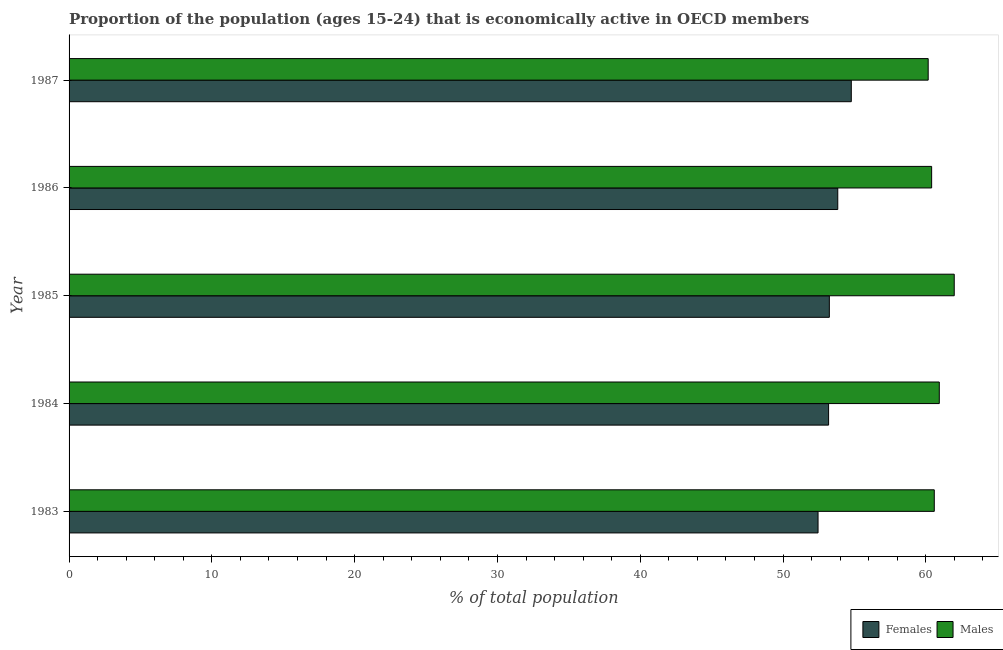How many groups of bars are there?
Offer a terse response. 5. Are the number of bars per tick equal to the number of legend labels?
Offer a terse response. Yes. Are the number of bars on each tick of the Y-axis equal?
Your answer should be very brief. Yes. How many bars are there on the 5th tick from the top?
Your answer should be compact. 2. In how many cases, is the number of bars for a given year not equal to the number of legend labels?
Keep it short and to the point. 0. What is the percentage of economically active male population in 1986?
Ensure brevity in your answer.  60.41. Across all years, what is the maximum percentage of economically active male population?
Ensure brevity in your answer.  61.99. Across all years, what is the minimum percentage of economically active female population?
Offer a terse response. 52.45. In which year was the percentage of economically active female population minimum?
Ensure brevity in your answer.  1983. What is the total percentage of economically active female population in the graph?
Your answer should be very brief. 267.5. What is the difference between the percentage of economically active female population in 1983 and that in 1985?
Keep it short and to the point. -0.79. What is the difference between the percentage of economically active male population in 1985 and the percentage of economically active female population in 1983?
Give a very brief answer. 9.54. What is the average percentage of economically active female population per year?
Your answer should be compact. 53.5. In the year 1983, what is the difference between the percentage of economically active female population and percentage of economically active male population?
Offer a terse response. -8.14. In how many years, is the percentage of economically active female population greater than 24 %?
Your response must be concise. 5. What is the ratio of the percentage of economically active male population in 1983 to that in 1987?
Your answer should be compact. 1.01. Is the percentage of economically active male population in 1983 less than that in 1984?
Give a very brief answer. Yes. What is the difference between the highest and the second highest percentage of economically active male population?
Give a very brief answer. 1.05. What is the difference between the highest and the lowest percentage of economically active female population?
Provide a short and direct response. 2.33. What does the 2nd bar from the top in 1985 represents?
Ensure brevity in your answer.  Females. What does the 1st bar from the bottom in 1986 represents?
Make the answer very short. Females. Are all the bars in the graph horizontal?
Give a very brief answer. Yes. How many years are there in the graph?
Your answer should be compact. 5. Does the graph contain any zero values?
Provide a short and direct response. No. How many legend labels are there?
Keep it short and to the point. 2. How are the legend labels stacked?
Offer a very short reply. Horizontal. What is the title of the graph?
Give a very brief answer. Proportion of the population (ages 15-24) that is economically active in OECD members. Does "Foreign liabilities" appear as one of the legend labels in the graph?
Make the answer very short. No. What is the label or title of the X-axis?
Your answer should be very brief. % of total population. What is the % of total population in Females in 1983?
Keep it short and to the point. 52.45. What is the % of total population of Males in 1983?
Offer a terse response. 60.59. What is the % of total population in Females in 1984?
Give a very brief answer. 53.19. What is the % of total population of Males in 1984?
Your answer should be very brief. 60.94. What is the % of total population of Females in 1985?
Your answer should be very brief. 53.24. What is the % of total population in Males in 1985?
Provide a short and direct response. 61.99. What is the % of total population in Females in 1986?
Keep it short and to the point. 53.83. What is the % of total population in Males in 1986?
Make the answer very short. 60.41. What is the % of total population of Females in 1987?
Your answer should be compact. 54.78. What is the % of total population in Males in 1987?
Your answer should be very brief. 60.17. Across all years, what is the maximum % of total population in Females?
Your answer should be very brief. 54.78. Across all years, what is the maximum % of total population of Males?
Offer a very short reply. 61.99. Across all years, what is the minimum % of total population of Females?
Provide a short and direct response. 52.45. Across all years, what is the minimum % of total population of Males?
Ensure brevity in your answer.  60.17. What is the total % of total population in Females in the graph?
Offer a terse response. 267.5. What is the total % of total population in Males in the graph?
Your answer should be very brief. 304.1. What is the difference between the % of total population in Females in 1983 and that in 1984?
Your answer should be very brief. -0.74. What is the difference between the % of total population in Males in 1983 and that in 1984?
Make the answer very short. -0.35. What is the difference between the % of total population in Females in 1983 and that in 1985?
Offer a very short reply. -0.79. What is the difference between the % of total population in Males in 1983 and that in 1985?
Ensure brevity in your answer.  -1.4. What is the difference between the % of total population in Females in 1983 and that in 1986?
Offer a very short reply. -1.38. What is the difference between the % of total population of Males in 1983 and that in 1986?
Make the answer very short. 0.18. What is the difference between the % of total population of Females in 1983 and that in 1987?
Your answer should be very brief. -2.33. What is the difference between the % of total population in Males in 1983 and that in 1987?
Provide a short and direct response. 0.43. What is the difference between the % of total population in Females in 1984 and that in 1985?
Your answer should be very brief. -0.05. What is the difference between the % of total population in Males in 1984 and that in 1985?
Offer a very short reply. -1.05. What is the difference between the % of total population in Females in 1984 and that in 1986?
Keep it short and to the point. -0.64. What is the difference between the % of total population in Males in 1984 and that in 1986?
Provide a succinct answer. 0.54. What is the difference between the % of total population in Females in 1984 and that in 1987?
Your answer should be very brief. -1.59. What is the difference between the % of total population of Males in 1984 and that in 1987?
Provide a succinct answer. 0.78. What is the difference between the % of total population in Females in 1985 and that in 1986?
Give a very brief answer. -0.59. What is the difference between the % of total population of Males in 1985 and that in 1986?
Your answer should be compact. 1.58. What is the difference between the % of total population of Females in 1985 and that in 1987?
Your answer should be very brief. -1.54. What is the difference between the % of total population of Males in 1985 and that in 1987?
Make the answer very short. 1.82. What is the difference between the % of total population in Females in 1986 and that in 1987?
Keep it short and to the point. -0.95. What is the difference between the % of total population of Males in 1986 and that in 1987?
Your answer should be very brief. 0.24. What is the difference between the % of total population of Females in 1983 and the % of total population of Males in 1984?
Make the answer very short. -8.49. What is the difference between the % of total population in Females in 1983 and the % of total population in Males in 1985?
Your response must be concise. -9.54. What is the difference between the % of total population of Females in 1983 and the % of total population of Males in 1986?
Offer a very short reply. -7.96. What is the difference between the % of total population in Females in 1983 and the % of total population in Males in 1987?
Provide a succinct answer. -7.71. What is the difference between the % of total population in Females in 1984 and the % of total population in Males in 1985?
Your response must be concise. -8.8. What is the difference between the % of total population in Females in 1984 and the % of total population in Males in 1986?
Your response must be concise. -7.22. What is the difference between the % of total population of Females in 1984 and the % of total population of Males in 1987?
Ensure brevity in your answer.  -6.98. What is the difference between the % of total population in Females in 1985 and the % of total population in Males in 1986?
Offer a terse response. -7.16. What is the difference between the % of total population of Females in 1985 and the % of total population of Males in 1987?
Make the answer very short. -6.92. What is the difference between the % of total population of Females in 1986 and the % of total population of Males in 1987?
Give a very brief answer. -6.33. What is the average % of total population of Females per year?
Provide a short and direct response. 53.5. What is the average % of total population of Males per year?
Keep it short and to the point. 60.82. In the year 1983, what is the difference between the % of total population in Females and % of total population in Males?
Offer a very short reply. -8.14. In the year 1984, what is the difference between the % of total population in Females and % of total population in Males?
Your response must be concise. -7.75. In the year 1985, what is the difference between the % of total population in Females and % of total population in Males?
Keep it short and to the point. -8.75. In the year 1986, what is the difference between the % of total population of Females and % of total population of Males?
Offer a very short reply. -6.57. In the year 1987, what is the difference between the % of total population in Females and % of total population in Males?
Ensure brevity in your answer.  -5.39. What is the ratio of the % of total population in Females in 1983 to that in 1984?
Offer a very short reply. 0.99. What is the ratio of the % of total population of Males in 1983 to that in 1984?
Make the answer very short. 0.99. What is the ratio of the % of total population of Females in 1983 to that in 1985?
Provide a short and direct response. 0.99. What is the ratio of the % of total population of Males in 1983 to that in 1985?
Ensure brevity in your answer.  0.98. What is the ratio of the % of total population in Females in 1983 to that in 1986?
Your response must be concise. 0.97. What is the ratio of the % of total population of Females in 1983 to that in 1987?
Your response must be concise. 0.96. What is the ratio of the % of total population in Males in 1983 to that in 1987?
Your answer should be very brief. 1.01. What is the ratio of the % of total population in Females in 1984 to that in 1985?
Offer a very short reply. 1. What is the ratio of the % of total population of Males in 1984 to that in 1985?
Your answer should be very brief. 0.98. What is the ratio of the % of total population of Males in 1984 to that in 1986?
Provide a short and direct response. 1.01. What is the ratio of the % of total population in Females in 1984 to that in 1987?
Give a very brief answer. 0.97. What is the ratio of the % of total population of Males in 1984 to that in 1987?
Keep it short and to the point. 1.01. What is the ratio of the % of total population of Females in 1985 to that in 1986?
Your answer should be compact. 0.99. What is the ratio of the % of total population in Males in 1985 to that in 1986?
Provide a short and direct response. 1.03. What is the ratio of the % of total population of Females in 1985 to that in 1987?
Keep it short and to the point. 0.97. What is the ratio of the % of total population of Males in 1985 to that in 1987?
Give a very brief answer. 1.03. What is the ratio of the % of total population in Females in 1986 to that in 1987?
Ensure brevity in your answer.  0.98. What is the difference between the highest and the second highest % of total population in Females?
Your answer should be very brief. 0.95. What is the difference between the highest and the second highest % of total population in Males?
Make the answer very short. 1.05. What is the difference between the highest and the lowest % of total population of Females?
Make the answer very short. 2.33. What is the difference between the highest and the lowest % of total population in Males?
Your answer should be compact. 1.82. 